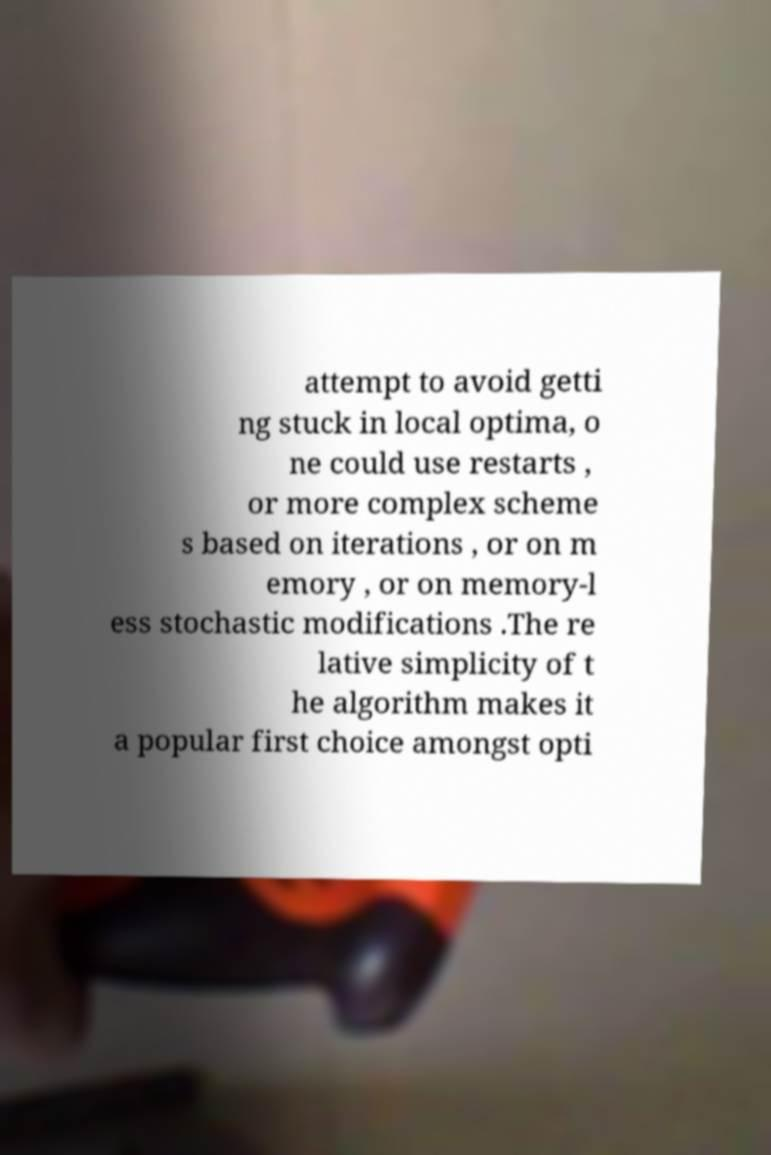For documentation purposes, I need the text within this image transcribed. Could you provide that? attempt to avoid getti ng stuck in local optima, o ne could use restarts , or more complex scheme s based on iterations , or on m emory , or on memory-l ess stochastic modifications .The re lative simplicity of t he algorithm makes it a popular first choice amongst opti 